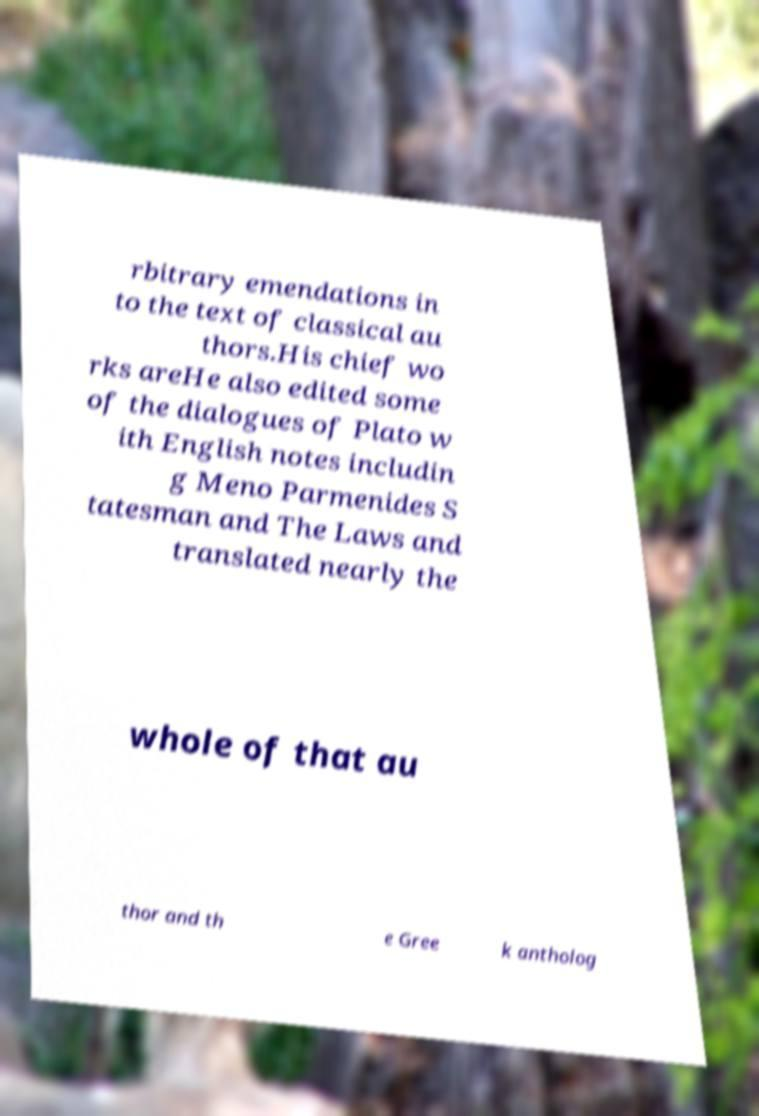Please read and relay the text visible in this image. What does it say? rbitrary emendations in to the text of classical au thors.His chief wo rks areHe also edited some of the dialogues of Plato w ith English notes includin g Meno Parmenides S tatesman and The Laws and translated nearly the whole of that au thor and th e Gree k antholog 